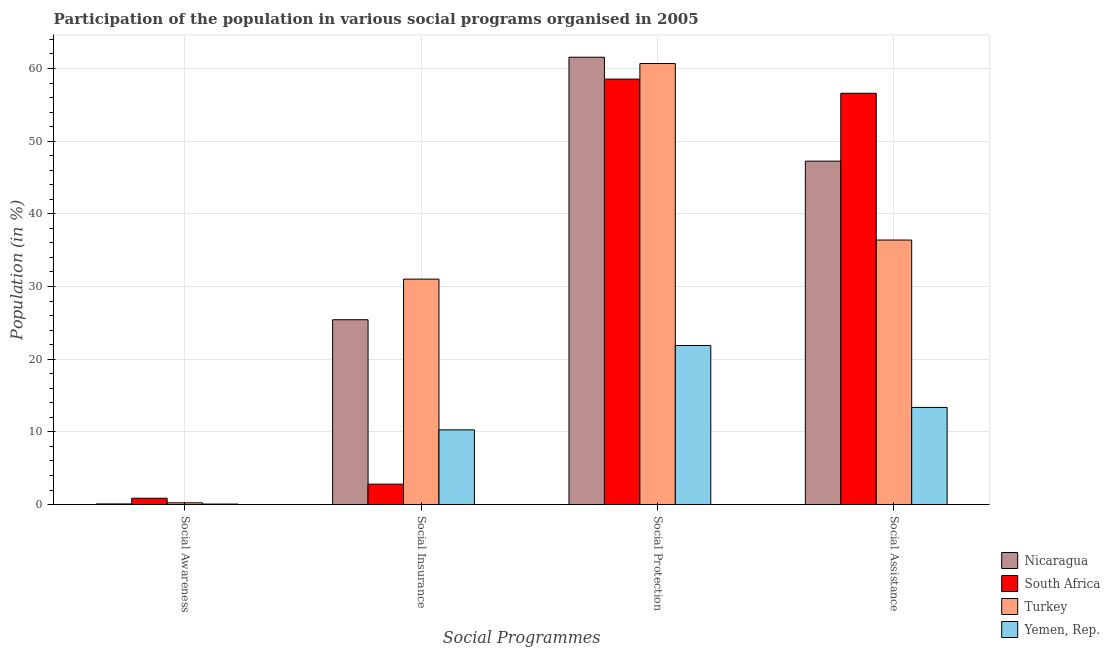How many different coloured bars are there?
Ensure brevity in your answer.  4. How many groups of bars are there?
Your response must be concise. 4. Are the number of bars per tick equal to the number of legend labels?
Offer a very short reply. Yes. What is the label of the 3rd group of bars from the left?
Give a very brief answer. Social Protection. What is the participation of population in social awareness programs in Yemen, Rep.?
Your answer should be very brief. 0.07. Across all countries, what is the maximum participation of population in social protection programs?
Your response must be concise. 61.55. Across all countries, what is the minimum participation of population in social insurance programs?
Provide a short and direct response. 2.81. In which country was the participation of population in social assistance programs maximum?
Keep it short and to the point. South Africa. In which country was the participation of population in social assistance programs minimum?
Offer a very short reply. Yemen, Rep. What is the total participation of population in social awareness programs in the graph?
Your response must be concise. 1.26. What is the difference between the participation of population in social awareness programs in South Africa and that in Yemen, Rep.?
Offer a very short reply. 0.8. What is the difference between the participation of population in social protection programs in Turkey and the participation of population in social awareness programs in Nicaragua?
Your answer should be very brief. 60.59. What is the average participation of population in social awareness programs per country?
Make the answer very short. 0.31. What is the difference between the participation of population in social awareness programs and participation of population in social assistance programs in Nicaragua?
Provide a short and direct response. -47.16. What is the ratio of the participation of population in social awareness programs in Nicaragua to that in Yemen, Rep.?
Your answer should be very brief. 1.32. Is the participation of population in social assistance programs in Yemen, Rep. less than that in Nicaragua?
Offer a terse response. Yes. What is the difference between the highest and the second highest participation of population in social protection programs?
Ensure brevity in your answer.  0.87. What is the difference between the highest and the lowest participation of population in social assistance programs?
Give a very brief answer. 43.22. Is it the case that in every country, the sum of the participation of population in social protection programs and participation of population in social insurance programs is greater than the sum of participation of population in social awareness programs and participation of population in social assistance programs?
Your response must be concise. No. What does the 1st bar from the left in Social Assistance represents?
Make the answer very short. Nicaragua. What does the 3rd bar from the right in Social Assistance represents?
Ensure brevity in your answer.  South Africa. Is it the case that in every country, the sum of the participation of population in social awareness programs and participation of population in social insurance programs is greater than the participation of population in social protection programs?
Your answer should be compact. No. Does the graph contain any zero values?
Ensure brevity in your answer.  No. Does the graph contain grids?
Your answer should be compact. Yes. How are the legend labels stacked?
Provide a succinct answer. Vertical. What is the title of the graph?
Keep it short and to the point. Participation of the population in various social programs organised in 2005. What is the label or title of the X-axis?
Provide a short and direct response. Social Programmes. What is the label or title of the Y-axis?
Give a very brief answer. Population (in %). What is the Population (in %) of Nicaragua in Social Awareness?
Your answer should be very brief. 0.09. What is the Population (in %) of South Africa in Social Awareness?
Your answer should be very brief. 0.87. What is the Population (in %) in Turkey in Social Awareness?
Keep it short and to the point. 0.24. What is the Population (in %) in Yemen, Rep. in Social Awareness?
Your response must be concise. 0.07. What is the Population (in %) of Nicaragua in Social Insurance?
Keep it short and to the point. 25.43. What is the Population (in %) of South Africa in Social Insurance?
Provide a short and direct response. 2.81. What is the Population (in %) in Turkey in Social Insurance?
Provide a short and direct response. 31.02. What is the Population (in %) of Yemen, Rep. in Social Insurance?
Offer a terse response. 10.27. What is the Population (in %) of Nicaragua in Social Protection?
Your answer should be compact. 61.55. What is the Population (in %) in South Africa in Social Protection?
Offer a terse response. 58.54. What is the Population (in %) of Turkey in Social Protection?
Make the answer very short. 60.68. What is the Population (in %) of Yemen, Rep. in Social Protection?
Your response must be concise. 21.88. What is the Population (in %) in Nicaragua in Social Assistance?
Provide a succinct answer. 47.25. What is the Population (in %) of South Africa in Social Assistance?
Make the answer very short. 56.59. What is the Population (in %) of Turkey in Social Assistance?
Provide a short and direct response. 36.39. What is the Population (in %) of Yemen, Rep. in Social Assistance?
Make the answer very short. 13.36. Across all Social Programmes, what is the maximum Population (in %) in Nicaragua?
Give a very brief answer. 61.55. Across all Social Programmes, what is the maximum Population (in %) of South Africa?
Make the answer very short. 58.54. Across all Social Programmes, what is the maximum Population (in %) in Turkey?
Ensure brevity in your answer.  60.68. Across all Social Programmes, what is the maximum Population (in %) of Yemen, Rep.?
Give a very brief answer. 21.88. Across all Social Programmes, what is the minimum Population (in %) of Nicaragua?
Provide a short and direct response. 0.09. Across all Social Programmes, what is the minimum Population (in %) of South Africa?
Make the answer very short. 0.87. Across all Social Programmes, what is the minimum Population (in %) of Turkey?
Your response must be concise. 0.24. Across all Social Programmes, what is the minimum Population (in %) of Yemen, Rep.?
Ensure brevity in your answer.  0.07. What is the total Population (in %) of Nicaragua in the graph?
Offer a very short reply. 134.31. What is the total Population (in %) of South Africa in the graph?
Give a very brief answer. 118.8. What is the total Population (in %) in Turkey in the graph?
Make the answer very short. 128.33. What is the total Population (in %) of Yemen, Rep. in the graph?
Keep it short and to the point. 45.59. What is the difference between the Population (in %) in Nicaragua in Social Awareness and that in Social Insurance?
Keep it short and to the point. -25.34. What is the difference between the Population (in %) of South Africa in Social Awareness and that in Social Insurance?
Your answer should be compact. -1.94. What is the difference between the Population (in %) of Turkey in Social Awareness and that in Social Insurance?
Ensure brevity in your answer.  -30.78. What is the difference between the Population (in %) in Yemen, Rep. in Social Awareness and that in Social Insurance?
Offer a very short reply. -10.21. What is the difference between the Population (in %) in Nicaragua in Social Awareness and that in Social Protection?
Your response must be concise. -61.46. What is the difference between the Population (in %) in South Africa in Social Awareness and that in Social Protection?
Ensure brevity in your answer.  -57.67. What is the difference between the Population (in %) of Turkey in Social Awareness and that in Social Protection?
Your answer should be compact. -60.44. What is the difference between the Population (in %) of Yemen, Rep. in Social Awareness and that in Social Protection?
Your response must be concise. -21.82. What is the difference between the Population (in %) in Nicaragua in Social Awareness and that in Social Assistance?
Make the answer very short. -47.16. What is the difference between the Population (in %) in South Africa in Social Awareness and that in Social Assistance?
Your response must be concise. -55.72. What is the difference between the Population (in %) in Turkey in Social Awareness and that in Social Assistance?
Keep it short and to the point. -36.15. What is the difference between the Population (in %) in Yemen, Rep. in Social Awareness and that in Social Assistance?
Provide a succinct answer. -13.3. What is the difference between the Population (in %) of Nicaragua in Social Insurance and that in Social Protection?
Give a very brief answer. -36.12. What is the difference between the Population (in %) in South Africa in Social Insurance and that in Social Protection?
Ensure brevity in your answer.  -55.73. What is the difference between the Population (in %) in Turkey in Social Insurance and that in Social Protection?
Provide a succinct answer. -29.66. What is the difference between the Population (in %) of Yemen, Rep. in Social Insurance and that in Social Protection?
Make the answer very short. -11.61. What is the difference between the Population (in %) of Nicaragua in Social Insurance and that in Social Assistance?
Offer a very short reply. -21.82. What is the difference between the Population (in %) of South Africa in Social Insurance and that in Social Assistance?
Offer a very short reply. -53.78. What is the difference between the Population (in %) of Turkey in Social Insurance and that in Social Assistance?
Offer a very short reply. -5.38. What is the difference between the Population (in %) of Yemen, Rep. in Social Insurance and that in Social Assistance?
Give a very brief answer. -3.09. What is the difference between the Population (in %) of Nicaragua in Social Protection and that in Social Assistance?
Offer a very short reply. 14.3. What is the difference between the Population (in %) in South Africa in Social Protection and that in Social Assistance?
Provide a short and direct response. 1.95. What is the difference between the Population (in %) of Turkey in Social Protection and that in Social Assistance?
Ensure brevity in your answer.  24.29. What is the difference between the Population (in %) of Yemen, Rep. in Social Protection and that in Social Assistance?
Your answer should be very brief. 8.52. What is the difference between the Population (in %) in Nicaragua in Social Awareness and the Population (in %) in South Africa in Social Insurance?
Make the answer very short. -2.72. What is the difference between the Population (in %) of Nicaragua in Social Awareness and the Population (in %) of Turkey in Social Insurance?
Provide a succinct answer. -30.93. What is the difference between the Population (in %) of Nicaragua in Social Awareness and the Population (in %) of Yemen, Rep. in Social Insurance?
Your response must be concise. -10.19. What is the difference between the Population (in %) in South Africa in Social Awareness and the Population (in %) in Turkey in Social Insurance?
Provide a succinct answer. -30.15. What is the difference between the Population (in %) of South Africa in Social Awareness and the Population (in %) of Yemen, Rep. in Social Insurance?
Keep it short and to the point. -9.41. What is the difference between the Population (in %) in Turkey in Social Awareness and the Population (in %) in Yemen, Rep. in Social Insurance?
Your response must be concise. -10.04. What is the difference between the Population (in %) in Nicaragua in Social Awareness and the Population (in %) in South Africa in Social Protection?
Keep it short and to the point. -58.45. What is the difference between the Population (in %) in Nicaragua in Social Awareness and the Population (in %) in Turkey in Social Protection?
Your response must be concise. -60.59. What is the difference between the Population (in %) of Nicaragua in Social Awareness and the Population (in %) of Yemen, Rep. in Social Protection?
Your response must be concise. -21.8. What is the difference between the Population (in %) of South Africa in Social Awareness and the Population (in %) of Turkey in Social Protection?
Offer a terse response. -59.81. What is the difference between the Population (in %) of South Africa in Social Awareness and the Population (in %) of Yemen, Rep. in Social Protection?
Provide a short and direct response. -21.02. What is the difference between the Population (in %) in Turkey in Social Awareness and the Population (in %) in Yemen, Rep. in Social Protection?
Your answer should be compact. -21.65. What is the difference between the Population (in %) of Nicaragua in Social Awareness and the Population (in %) of South Africa in Social Assistance?
Ensure brevity in your answer.  -56.5. What is the difference between the Population (in %) of Nicaragua in Social Awareness and the Population (in %) of Turkey in Social Assistance?
Give a very brief answer. -36.31. What is the difference between the Population (in %) of Nicaragua in Social Awareness and the Population (in %) of Yemen, Rep. in Social Assistance?
Your response must be concise. -13.28. What is the difference between the Population (in %) of South Africa in Social Awareness and the Population (in %) of Turkey in Social Assistance?
Give a very brief answer. -35.53. What is the difference between the Population (in %) of South Africa in Social Awareness and the Population (in %) of Yemen, Rep. in Social Assistance?
Your answer should be compact. -12.5. What is the difference between the Population (in %) of Turkey in Social Awareness and the Population (in %) of Yemen, Rep. in Social Assistance?
Offer a terse response. -13.12. What is the difference between the Population (in %) of Nicaragua in Social Insurance and the Population (in %) of South Africa in Social Protection?
Offer a terse response. -33.11. What is the difference between the Population (in %) of Nicaragua in Social Insurance and the Population (in %) of Turkey in Social Protection?
Provide a succinct answer. -35.25. What is the difference between the Population (in %) in Nicaragua in Social Insurance and the Population (in %) in Yemen, Rep. in Social Protection?
Your answer should be compact. 3.54. What is the difference between the Population (in %) in South Africa in Social Insurance and the Population (in %) in Turkey in Social Protection?
Make the answer very short. -57.87. What is the difference between the Population (in %) of South Africa in Social Insurance and the Population (in %) of Yemen, Rep. in Social Protection?
Give a very brief answer. -19.08. What is the difference between the Population (in %) of Turkey in Social Insurance and the Population (in %) of Yemen, Rep. in Social Protection?
Ensure brevity in your answer.  9.13. What is the difference between the Population (in %) of Nicaragua in Social Insurance and the Population (in %) of South Africa in Social Assistance?
Ensure brevity in your answer.  -31.16. What is the difference between the Population (in %) in Nicaragua in Social Insurance and the Population (in %) in Turkey in Social Assistance?
Your response must be concise. -10.96. What is the difference between the Population (in %) of Nicaragua in Social Insurance and the Population (in %) of Yemen, Rep. in Social Assistance?
Offer a terse response. 12.07. What is the difference between the Population (in %) of South Africa in Social Insurance and the Population (in %) of Turkey in Social Assistance?
Make the answer very short. -33.58. What is the difference between the Population (in %) of South Africa in Social Insurance and the Population (in %) of Yemen, Rep. in Social Assistance?
Make the answer very short. -10.55. What is the difference between the Population (in %) in Turkey in Social Insurance and the Population (in %) in Yemen, Rep. in Social Assistance?
Ensure brevity in your answer.  17.65. What is the difference between the Population (in %) of Nicaragua in Social Protection and the Population (in %) of South Africa in Social Assistance?
Make the answer very short. 4.96. What is the difference between the Population (in %) of Nicaragua in Social Protection and the Population (in %) of Turkey in Social Assistance?
Your answer should be compact. 25.15. What is the difference between the Population (in %) of Nicaragua in Social Protection and the Population (in %) of Yemen, Rep. in Social Assistance?
Make the answer very short. 48.18. What is the difference between the Population (in %) of South Africa in Social Protection and the Population (in %) of Turkey in Social Assistance?
Offer a very short reply. 22.14. What is the difference between the Population (in %) in South Africa in Social Protection and the Population (in %) in Yemen, Rep. in Social Assistance?
Make the answer very short. 45.17. What is the difference between the Population (in %) of Turkey in Social Protection and the Population (in %) of Yemen, Rep. in Social Assistance?
Give a very brief answer. 47.32. What is the average Population (in %) of Nicaragua per Social Programmes?
Your answer should be compact. 33.58. What is the average Population (in %) of South Africa per Social Programmes?
Keep it short and to the point. 29.7. What is the average Population (in %) of Turkey per Social Programmes?
Your answer should be very brief. 32.08. What is the average Population (in %) in Yemen, Rep. per Social Programmes?
Your response must be concise. 11.4. What is the difference between the Population (in %) in Nicaragua and Population (in %) in South Africa in Social Awareness?
Offer a very short reply. -0.78. What is the difference between the Population (in %) in Nicaragua and Population (in %) in Turkey in Social Awareness?
Make the answer very short. -0.15. What is the difference between the Population (in %) in Nicaragua and Population (in %) in Yemen, Rep. in Social Awareness?
Ensure brevity in your answer.  0.02. What is the difference between the Population (in %) in South Africa and Population (in %) in Turkey in Social Awareness?
Ensure brevity in your answer.  0.63. What is the difference between the Population (in %) in South Africa and Population (in %) in Yemen, Rep. in Social Awareness?
Ensure brevity in your answer.  0.8. What is the difference between the Population (in %) of Turkey and Population (in %) of Yemen, Rep. in Social Awareness?
Ensure brevity in your answer.  0.17. What is the difference between the Population (in %) of Nicaragua and Population (in %) of South Africa in Social Insurance?
Your response must be concise. 22.62. What is the difference between the Population (in %) in Nicaragua and Population (in %) in Turkey in Social Insurance?
Offer a very short reply. -5.59. What is the difference between the Population (in %) in Nicaragua and Population (in %) in Yemen, Rep. in Social Insurance?
Ensure brevity in your answer.  15.16. What is the difference between the Population (in %) in South Africa and Population (in %) in Turkey in Social Insurance?
Offer a very short reply. -28.21. What is the difference between the Population (in %) in South Africa and Population (in %) in Yemen, Rep. in Social Insurance?
Your answer should be very brief. -7.47. What is the difference between the Population (in %) of Turkey and Population (in %) of Yemen, Rep. in Social Insurance?
Provide a succinct answer. 20.74. What is the difference between the Population (in %) in Nicaragua and Population (in %) in South Africa in Social Protection?
Give a very brief answer. 3.01. What is the difference between the Population (in %) of Nicaragua and Population (in %) of Turkey in Social Protection?
Your answer should be very brief. 0.87. What is the difference between the Population (in %) in Nicaragua and Population (in %) in Yemen, Rep. in Social Protection?
Your answer should be compact. 39.66. What is the difference between the Population (in %) in South Africa and Population (in %) in Turkey in Social Protection?
Provide a succinct answer. -2.14. What is the difference between the Population (in %) in South Africa and Population (in %) in Yemen, Rep. in Social Protection?
Offer a very short reply. 36.65. What is the difference between the Population (in %) in Turkey and Population (in %) in Yemen, Rep. in Social Protection?
Ensure brevity in your answer.  38.79. What is the difference between the Population (in %) of Nicaragua and Population (in %) of South Africa in Social Assistance?
Provide a succinct answer. -9.34. What is the difference between the Population (in %) of Nicaragua and Population (in %) of Turkey in Social Assistance?
Provide a short and direct response. 10.85. What is the difference between the Population (in %) in Nicaragua and Population (in %) in Yemen, Rep. in Social Assistance?
Keep it short and to the point. 33.88. What is the difference between the Population (in %) in South Africa and Population (in %) in Turkey in Social Assistance?
Offer a terse response. 20.19. What is the difference between the Population (in %) of South Africa and Population (in %) of Yemen, Rep. in Social Assistance?
Offer a terse response. 43.22. What is the difference between the Population (in %) in Turkey and Population (in %) in Yemen, Rep. in Social Assistance?
Ensure brevity in your answer.  23.03. What is the ratio of the Population (in %) of Nicaragua in Social Awareness to that in Social Insurance?
Make the answer very short. 0. What is the ratio of the Population (in %) in South Africa in Social Awareness to that in Social Insurance?
Your answer should be very brief. 0.31. What is the ratio of the Population (in %) in Turkey in Social Awareness to that in Social Insurance?
Make the answer very short. 0.01. What is the ratio of the Population (in %) of Yemen, Rep. in Social Awareness to that in Social Insurance?
Offer a terse response. 0.01. What is the ratio of the Population (in %) in Nicaragua in Social Awareness to that in Social Protection?
Provide a succinct answer. 0. What is the ratio of the Population (in %) of South Africa in Social Awareness to that in Social Protection?
Your answer should be compact. 0.01. What is the ratio of the Population (in %) of Turkey in Social Awareness to that in Social Protection?
Your answer should be compact. 0. What is the ratio of the Population (in %) of Yemen, Rep. in Social Awareness to that in Social Protection?
Your answer should be compact. 0. What is the ratio of the Population (in %) of Nicaragua in Social Awareness to that in Social Assistance?
Keep it short and to the point. 0. What is the ratio of the Population (in %) in South Africa in Social Awareness to that in Social Assistance?
Ensure brevity in your answer.  0.02. What is the ratio of the Population (in %) of Turkey in Social Awareness to that in Social Assistance?
Your answer should be compact. 0.01. What is the ratio of the Population (in %) in Yemen, Rep. in Social Awareness to that in Social Assistance?
Your response must be concise. 0. What is the ratio of the Population (in %) in Nicaragua in Social Insurance to that in Social Protection?
Keep it short and to the point. 0.41. What is the ratio of the Population (in %) of South Africa in Social Insurance to that in Social Protection?
Give a very brief answer. 0.05. What is the ratio of the Population (in %) of Turkey in Social Insurance to that in Social Protection?
Offer a terse response. 0.51. What is the ratio of the Population (in %) of Yemen, Rep. in Social Insurance to that in Social Protection?
Keep it short and to the point. 0.47. What is the ratio of the Population (in %) in Nicaragua in Social Insurance to that in Social Assistance?
Keep it short and to the point. 0.54. What is the ratio of the Population (in %) in South Africa in Social Insurance to that in Social Assistance?
Offer a very short reply. 0.05. What is the ratio of the Population (in %) in Turkey in Social Insurance to that in Social Assistance?
Keep it short and to the point. 0.85. What is the ratio of the Population (in %) in Yemen, Rep. in Social Insurance to that in Social Assistance?
Make the answer very short. 0.77. What is the ratio of the Population (in %) in Nicaragua in Social Protection to that in Social Assistance?
Offer a very short reply. 1.3. What is the ratio of the Population (in %) of South Africa in Social Protection to that in Social Assistance?
Provide a short and direct response. 1.03. What is the ratio of the Population (in %) in Turkey in Social Protection to that in Social Assistance?
Offer a terse response. 1.67. What is the ratio of the Population (in %) in Yemen, Rep. in Social Protection to that in Social Assistance?
Ensure brevity in your answer.  1.64. What is the difference between the highest and the second highest Population (in %) of Nicaragua?
Make the answer very short. 14.3. What is the difference between the highest and the second highest Population (in %) of South Africa?
Keep it short and to the point. 1.95. What is the difference between the highest and the second highest Population (in %) of Turkey?
Ensure brevity in your answer.  24.29. What is the difference between the highest and the second highest Population (in %) in Yemen, Rep.?
Your answer should be compact. 8.52. What is the difference between the highest and the lowest Population (in %) of Nicaragua?
Your response must be concise. 61.46. What is the difference between the highest and the lowest Population (in %) in South Africa?
Keep it short and to the point. 57.67. What is the difference between the highest and the lowest Population (in %) of Turkey?
Offer a very short reply. 60.44. What is the difference between the highest and the lowest Population (in %) in Yemen, Rep.?
Make the answer very short. 21.82. 